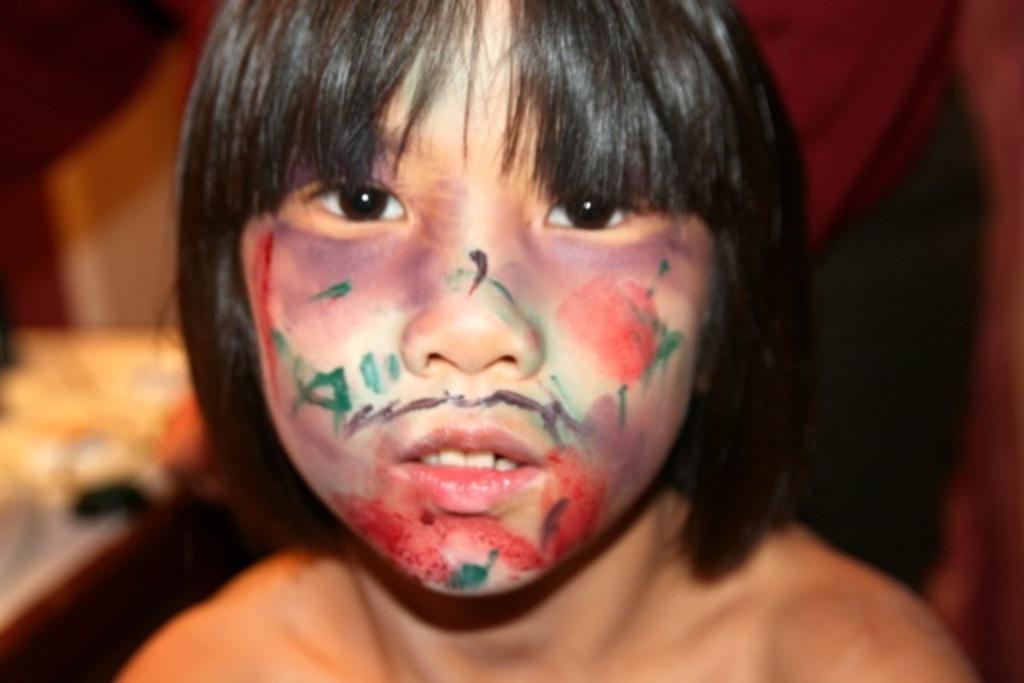Please provide a concise description of this image. There is a zoom in picture a face of a kid as we can see in the middle of this image. 